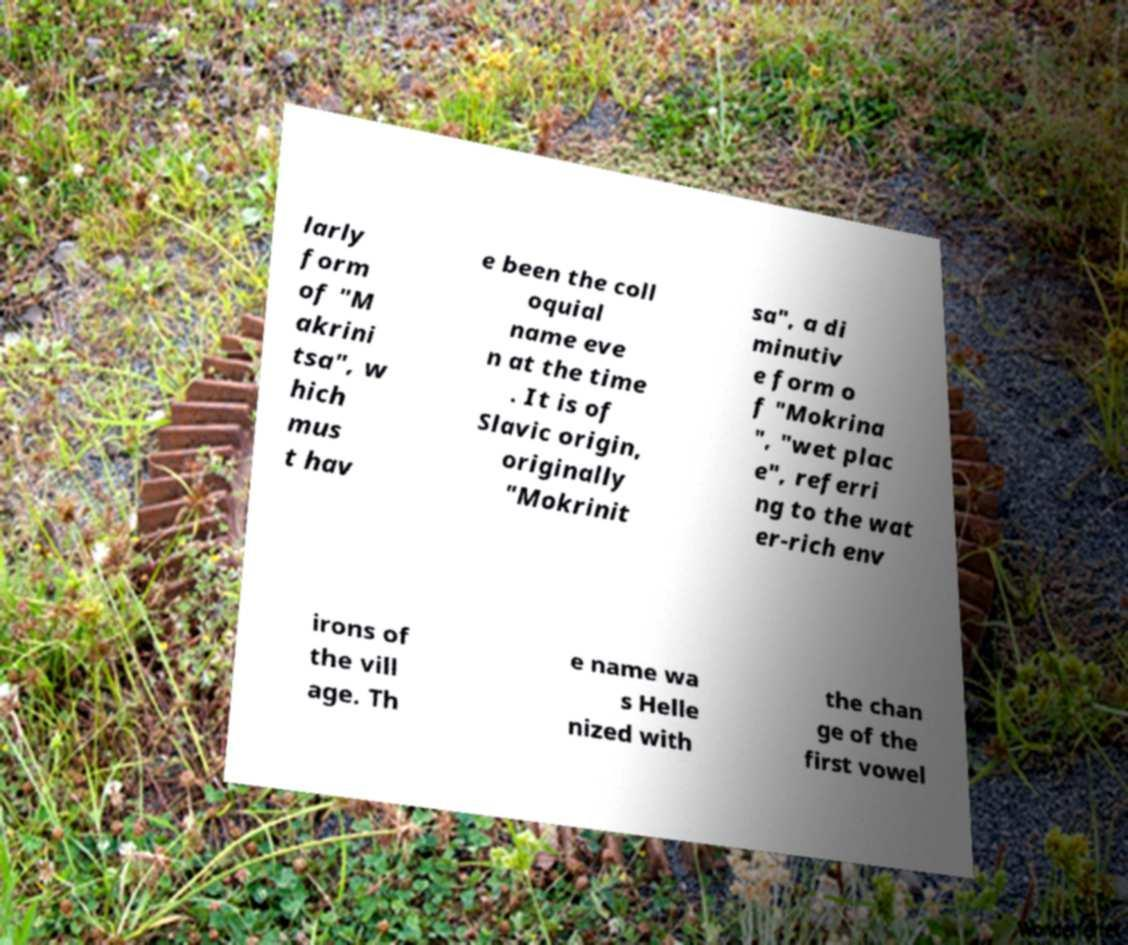Can you accurately transcribe the text from the provided image for me? larly form of "M akrini tsa", w hich mus t hav e been the coll oquial name eve n at the time . It is of Slavic origin, originally "Mokrinit sa", a di minutiv e form o f "Mokrina ", "wet plac e", referri ng to the wat er-rich env irons of the vill age. Th e name wa s Helle nized with the chan ge of the first vowel 